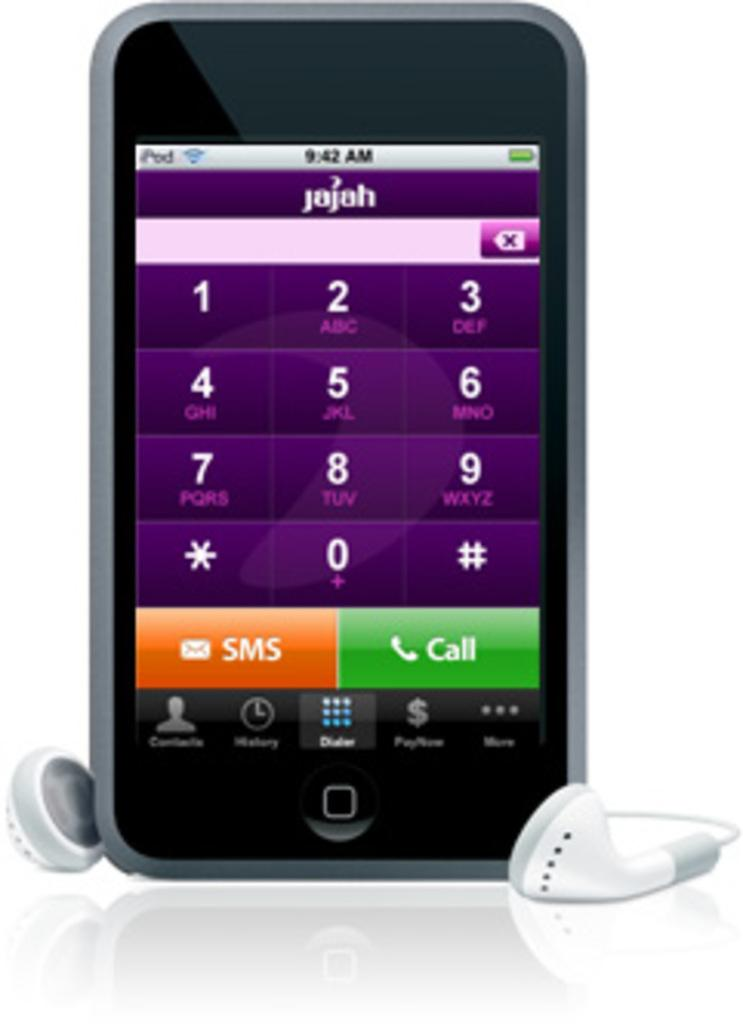<image>
Describe the image concisely. an ipod showing that it is 9:42 am on it 